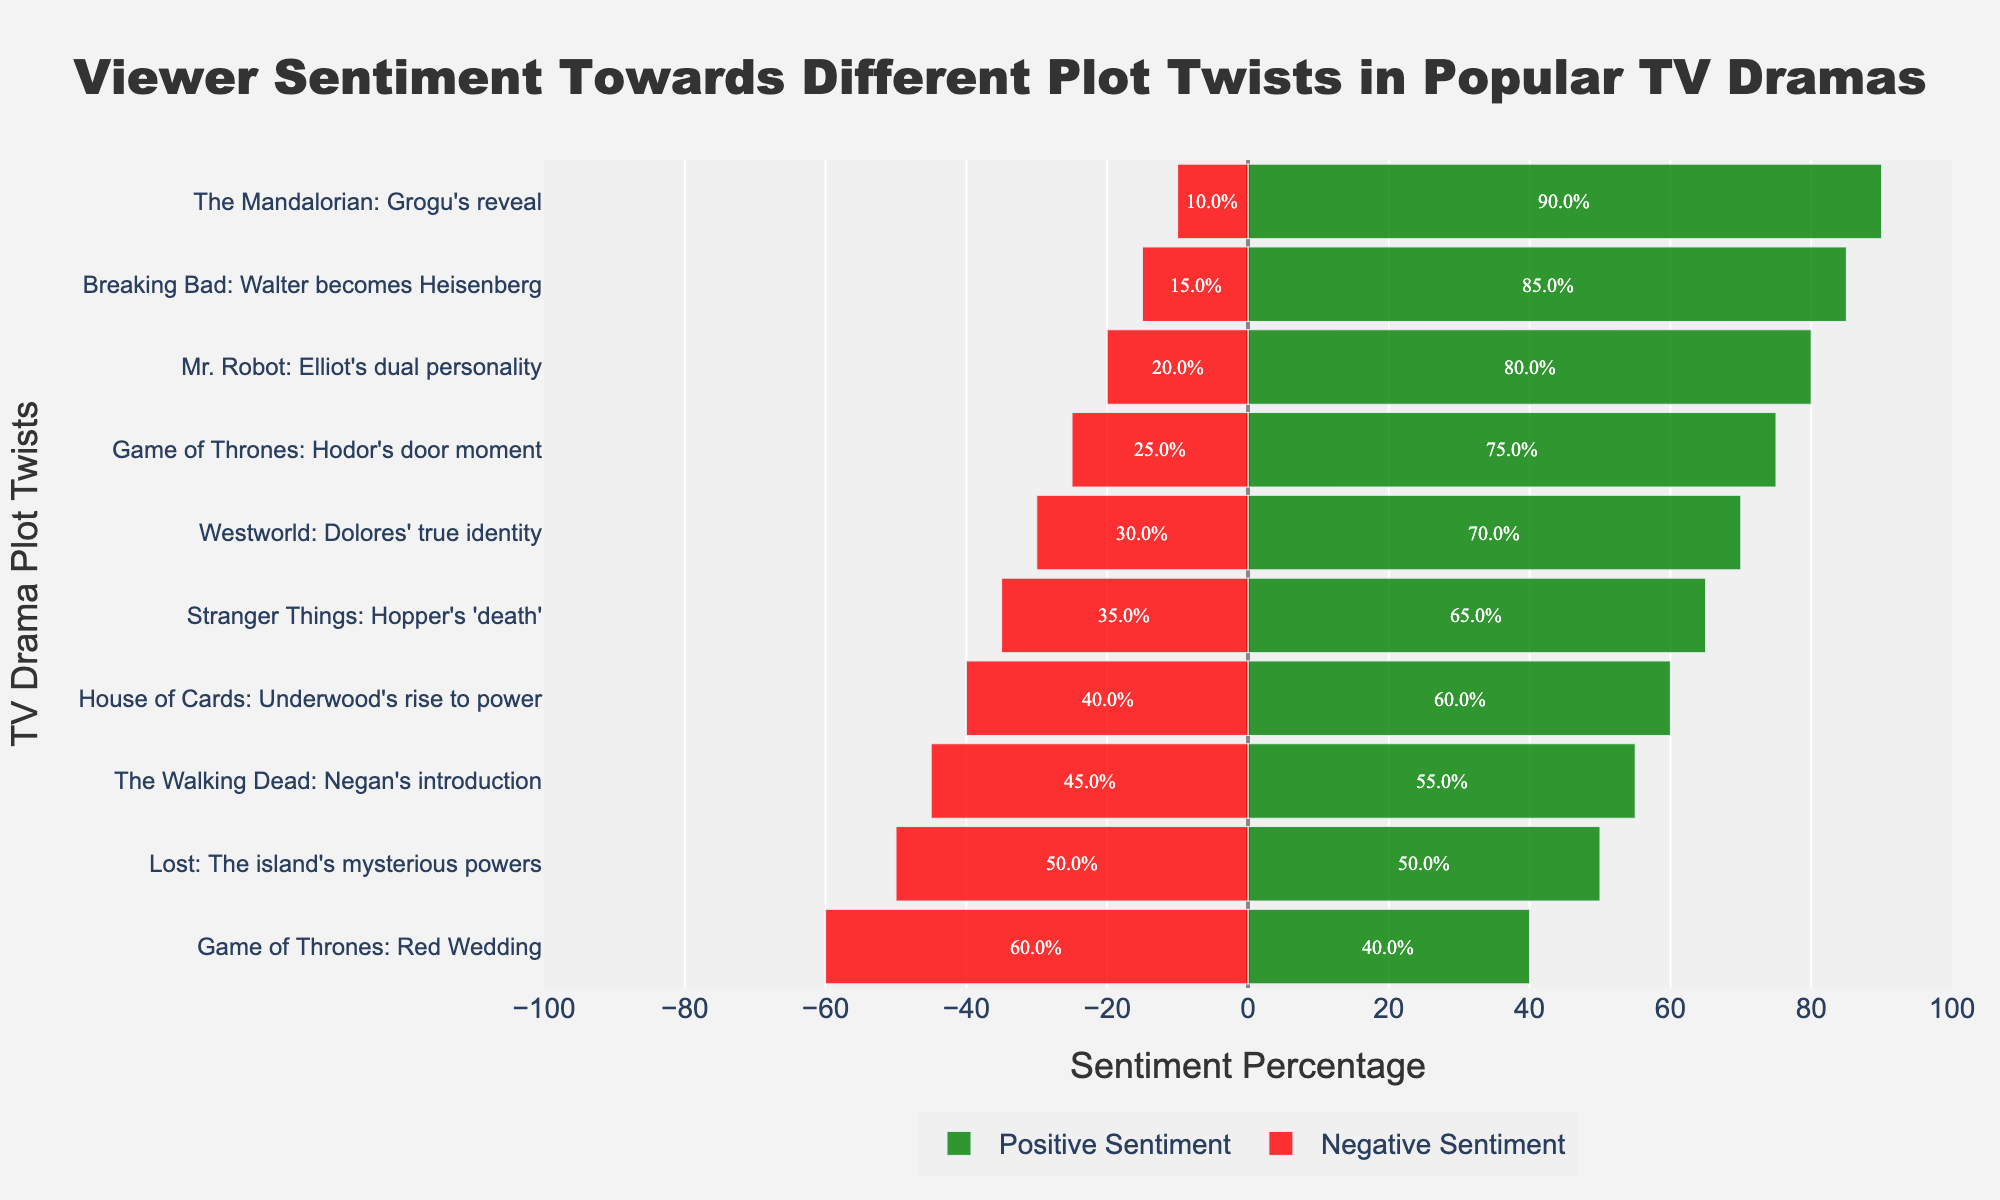What's the most positively received plot twist? The most positively received plot twist can be identified by looking for the plot with the longest green bar on the right side. "The Mandalorian: Grogu's reveal" has the longest green bar, indicating 90% positive sentiment.
Answer: "The Mandalorian: Grogu's reveal" Which plot twist has the highest negative sentiment? Look for the plot twist with the longest red bar on the left side. "Game of Thrones: Red Wedding" has the longest red bar, indicating 60% negative sentiment.
Answer: "Game of Thrones: Red Wedding" How many plot twists have a negative sentiment percentage of 40% or more? Count the plot twists where the length of the red bar meets or exceeds 40%. There are five plot twists: "Game of Thrones: Red Wedding," "Stranger Things: Hopper's 'death'," "Westworld: Dolores' true identity," "Lost: The island's mysterious powers," and "House of Cards: Underwood's rise to power."
Answer: 5 What's the total combined sentiment percentage for "Breaking Bad: Walter becomes Heisenberg"? Add the positive sentiment percentage (85%) to the absolute value of the negative sentiment percentage (15%). So, 85% + 15% = 100%.
Answer: 100% Which two plot twists have the closest positive sentiment percentages? Compare the lengths of the green bars to find plot twists with similar lengths. "Westworld: Dolores' true identity" (70%) and "Underwood's rise to power" (60%) are close, but "The Walking Dead: Negan's introduction" (55%) is closer, matching "Underwood's rise to power."
Answer: "Mr. Robot: Elliot's dual personality" and "Breaking Bad: Walter becomes Heisenberg" Which plot twist has an equal percentage of positive and negative sentiments? Look for the plot twist where the green and red bars have approximately the same length. "Lost: The island's mysterious powers" has equal green and red bars, with each being 50%.
Answer: "Lost: The island's mysterious powers" For "Stranger Things: Hopper's 'death'," what's the difference between the positive and negative sentiments? Subtract the negative sentiment percentage from the positive sentiment percentage: 65% (positive) - 35% (negative) = 30%.
Answer: 30% How does the viewer sentiment for "Game of Thrones: Hodor's door moment" compare to "The Walking Dead: Negan's introduction"? Compare the lengths of the green and red bars of both plot twists. "Game of Thrones: Hodor's door moment" has a higher positive sentiment (75%) and lower negative sentiment (25%) than "The Walking Dead: Negan's introduction" (55% positive, 45% negative).
Answer: "Game of Thrones: Hodor's door moment" is more positively received What's the median value of negative sentiment percentages across all plot twists? Organize the negative sentiment percentages in ascending order: [10, 15, 20, 25, 30, 35, 40, 45, 50, 60]. The median value is the middle value in the ordered list. With 10 values, the median is the average of the 5th and 6th values, i.e., (30% + 35%) / 2 = 32.5%.
Answer: 32.5% Which plot twists have higher positive sentiment percentages than "House of Cards: Underwood's rise to power"? Compare the positive sentiment percentages of other plot twists to the 60% positive sentiment of "House of Cards." Those with higher percentages are "Breaking Bad: Walter becomes Heisenberg" (85%), "Game of Thrones: Hodor's door moment" (75%), "The Mandalorian: Grogu's reveal" (90%), "Stranger Things: Hopper's 'death'" (65%), "Westworld: Dolores' true identity" (70%), and "Mr. Robot: Elliot's dual personality" (80%).
Answer: 6 plot twists 